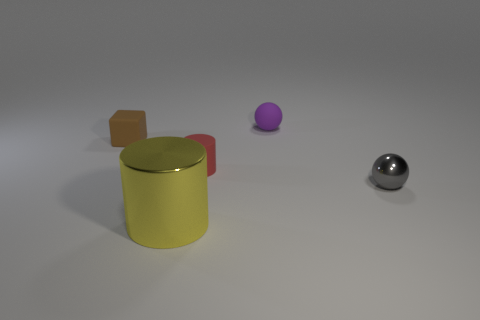What time of day does the lighting suggest in this image? The image doesn't necessarily suggest a particular time of day as it appears to be studio lighting, which is consistent and controlled, not indicative of natural lighting changes over time.  Could the objects in the image have functional purposes, or do they seem decorative? Without additional context, it's difficult to determine the exact purpose of the objects. The large cylinder with a lid could potentially be a container, while the small cube and the spherical shapes could be ornamental, educational, or part of a larger object or set. 